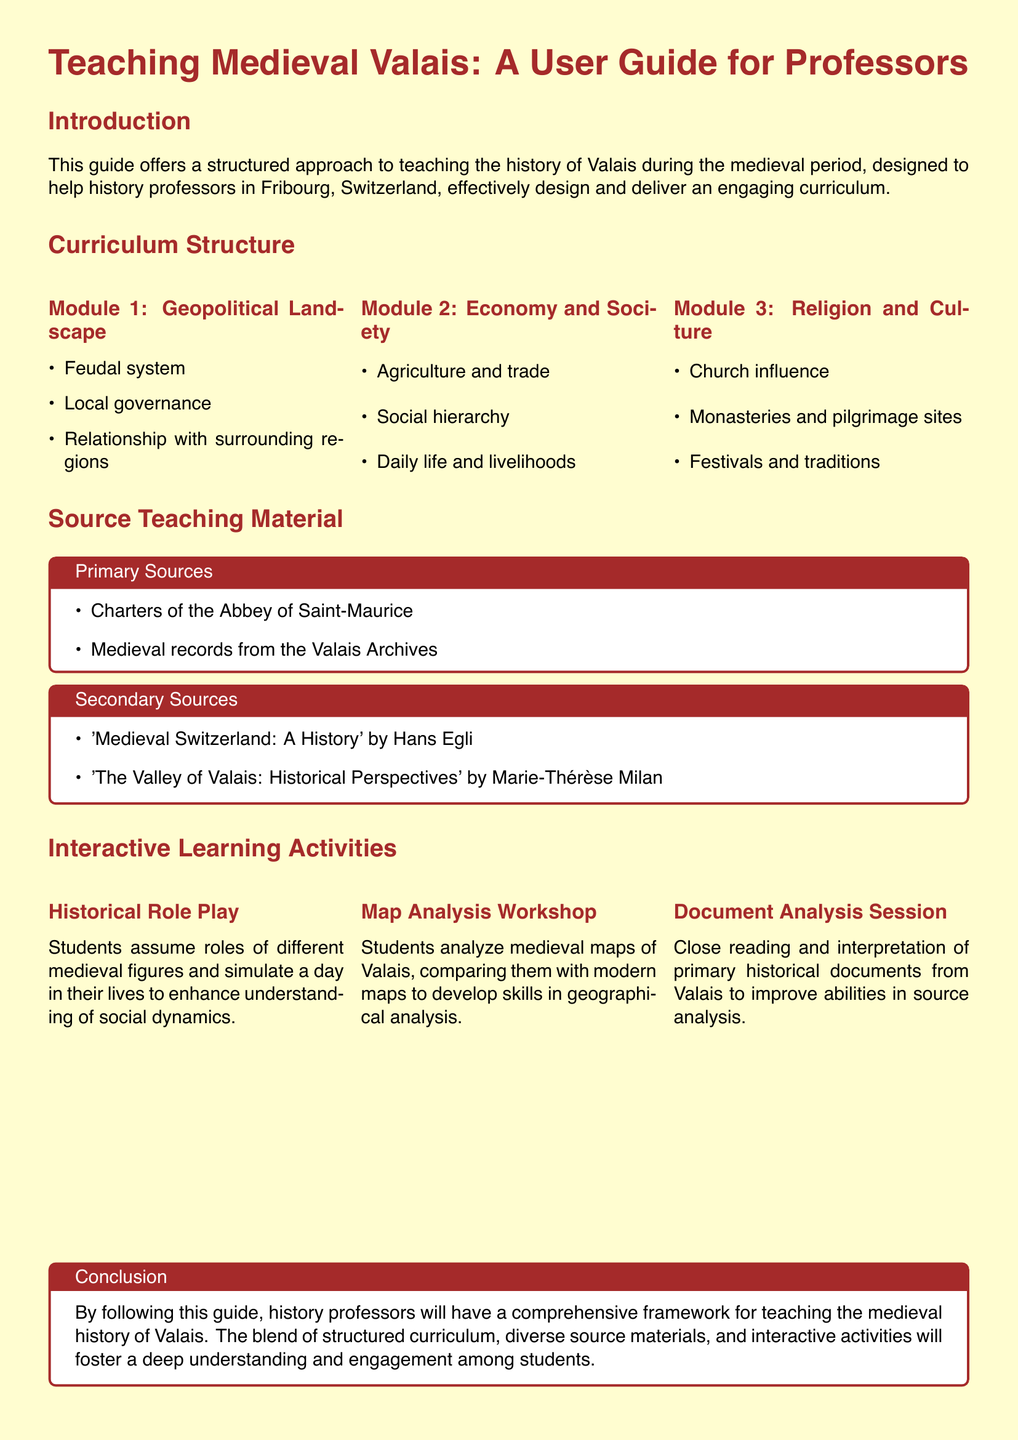What is the title of the user guide? The title of the user guide is specified in the document’s header section.
Answer: Teaching Medieval Valais: A User Guide for Professors How many modules are listed in the curriculum structure? The number of modules is noted in the curriculum structure section of the document.
Answer: 3 What is the title of the first module in the curriculum? The first module’s title is presented as part of the curriculum structure in the document.
Answer: Geopolitical Landscape Who is the author of the secondary source 'Medieval Switzerland: A History'? The author is mentioned in the source teaching material section of the document.
Answer: Hans Egli What type of interactive activity involves simulating a day in the life of medieval figures? This activity is described in the interactive learning activities section of the document.
Answer: Historical Role Play Which primary source document is associated with the Abbey of Saint-Maurice? The primary source related to this institution is listed in the source teaching material section.
Answer: Charters of the Abbey of Saint-Maurice What is the objective of the Map Analysis Workshop? The aim is explained in the context of interactive learning activities found in the document.
Answer: Geographical analysis What type of source materials does the guide suggest for teaching? The document categorizes teaching materials into two distinct types to aid in sourcing.
Answer: Primary and Secondary Sources 